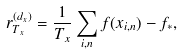Convert formula to latex. <formula><loc_0><loc_0><loc_500><loc_500>r _ { T _ { x } } ^ { ( d _ { x } ) } = \frac { 1 } { T _ { x } } \sum _ { i , n } f ( x _ { i , n } ) - f _ { * } ,</formula> 